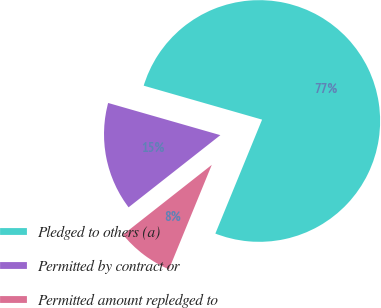<chart> <loc_0><loc_0><loc_500><loc_500><pie_chart><fcel>Pledged to others (a)<fcel>Permitted by contract or<fcel>Permitted amount repledged to<nl><fcel>76.75%<fcel>15.05%<fcel>8.2%<nl></chart> 